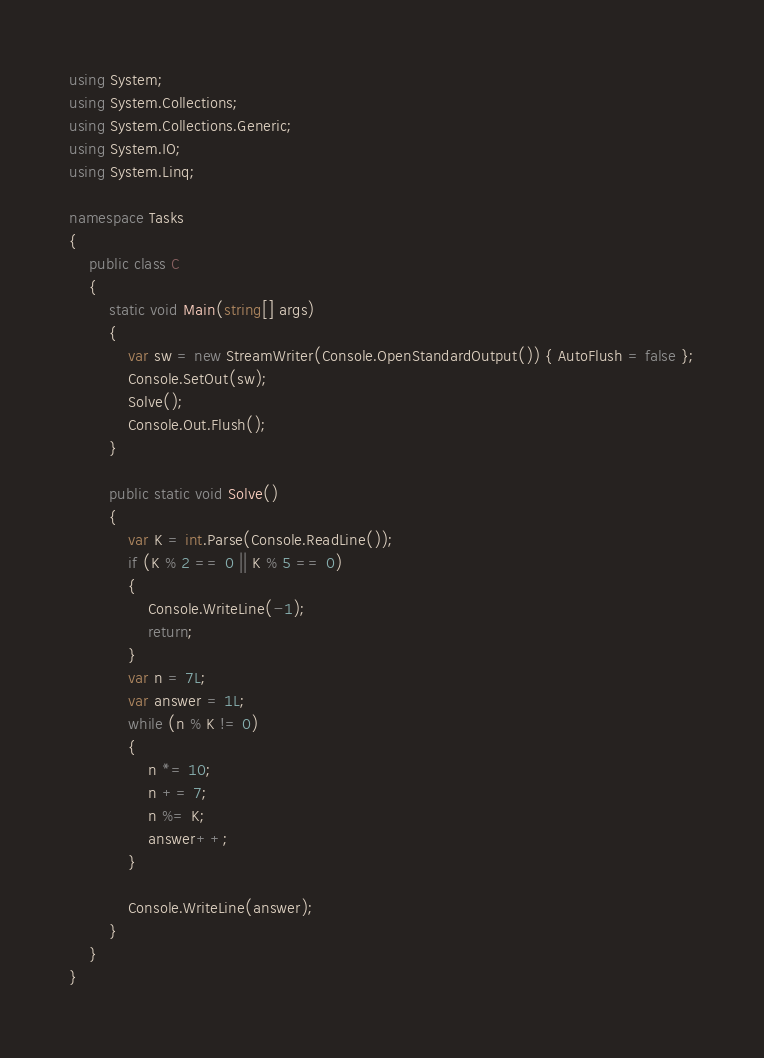<code> <loc_0><loc_0><loc_500><loc_500><_C#_>using System;
using System.Collections;
using System.Collections.Generic;
using System.IO;
using System.Linq;

namespace Tasks
{
    public class C
    {
        static void Main(string[] args)
        {
            var sw = new StreamWriter(Console.OpenStandardOutput()) { AutoFlush = false };
            Console.SetOut(sw);
            Solve();
            Console.Out.Flush();
        }

        public static void Solve()
        {
            var K = int.Parse(Console.ReadLine());
            if (K % 2 == 0 || K % 5 == 0)
            {
                Console.WriteLine(-1);
                return;
            }
            var n = 7L;
            var answer = 1L;
            while (n % K != 0)
            {
                n *= 10;
                n += 7;
                n %= K;
                answer++;
            }

            Console.WriteLine(answer);
        }
    }
}
</code> 